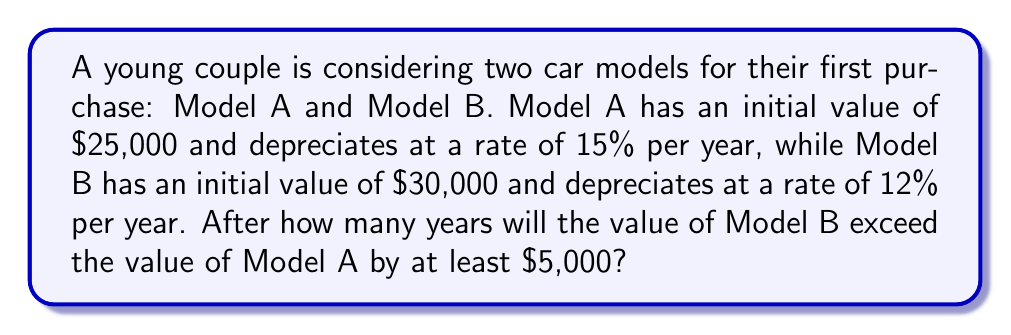Can you solve this math problem? Let's approach this problem step by step:

1) First, we need to express the value of each car as a function of time:

   Model A: $A(t) = 25000 \cdot (1 - 0.15)^t = 25000 \cdot 0.85^t$
   Model B: $B(t) = 30000 \cdot (1 - 0.12)^t = 30000 \cdot 0.88^t$

2) We want to find when $B(t) - A(t) \geq 5000$:

   $30000 \cdot 0.88^t - 25000 \cdot 0.85^t \geq 5000$

3) This inequality is complex to solve analytically, so we'll use a numerical approach. Let's create a table of values:

   t | Model A | Model B | Difference
   0 | 25000   | 30000   | 5000
   1 | 21250   | 26400   | 5150
   2 | 18062.5 | 23232   | 5169.5
   3 | 15353.1 | 20444.2 | 5091.1
   4 | 13050.2 | 17990.9 | 4940.7
   ...

4) We can see that the difference starts to decrease after year 2. This means that year 2 is the last year where the difference is at least $5000.

5) To verify, we can calculate the exact values for year 2:

   $A(2) = 25000 \cdot 0.85^2 = 18062.50$
   $B(2) = 30000 \cdot 0.88^2 = 23232.00$
   
   $B(2) - A(2) = 23232.00 - 18062.50 = 5169.50$

6) For year 3:

   $A(3) = 25000 \cdot 0.85^3 = 15353.13$
   $B(3) = 30000 \cdot 0.88^3 = 20444.16$
   
   $B(3) - A(3) = 20444.16 - 15353.13 = 5091.03$

   Which is less than $5000.
Answer: The value of Model B will exceed the value of Model A by at least $5,000 for 2 years. 